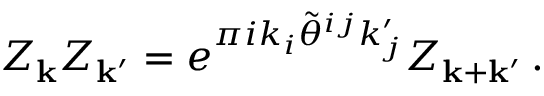<formula> <loc_0><loc_0><loc_500><loc_500>Z _ { k } Z _ { { k } ^ { \prime } } = e ^ { \pi i k _ { i } \tilde { \theta } ^ { i j } k _ { j } ^ { \prime } } Z _ { { k } + { k } ^ { \prime } } \, .</formula> 